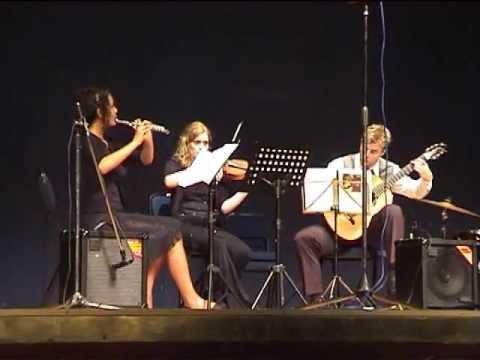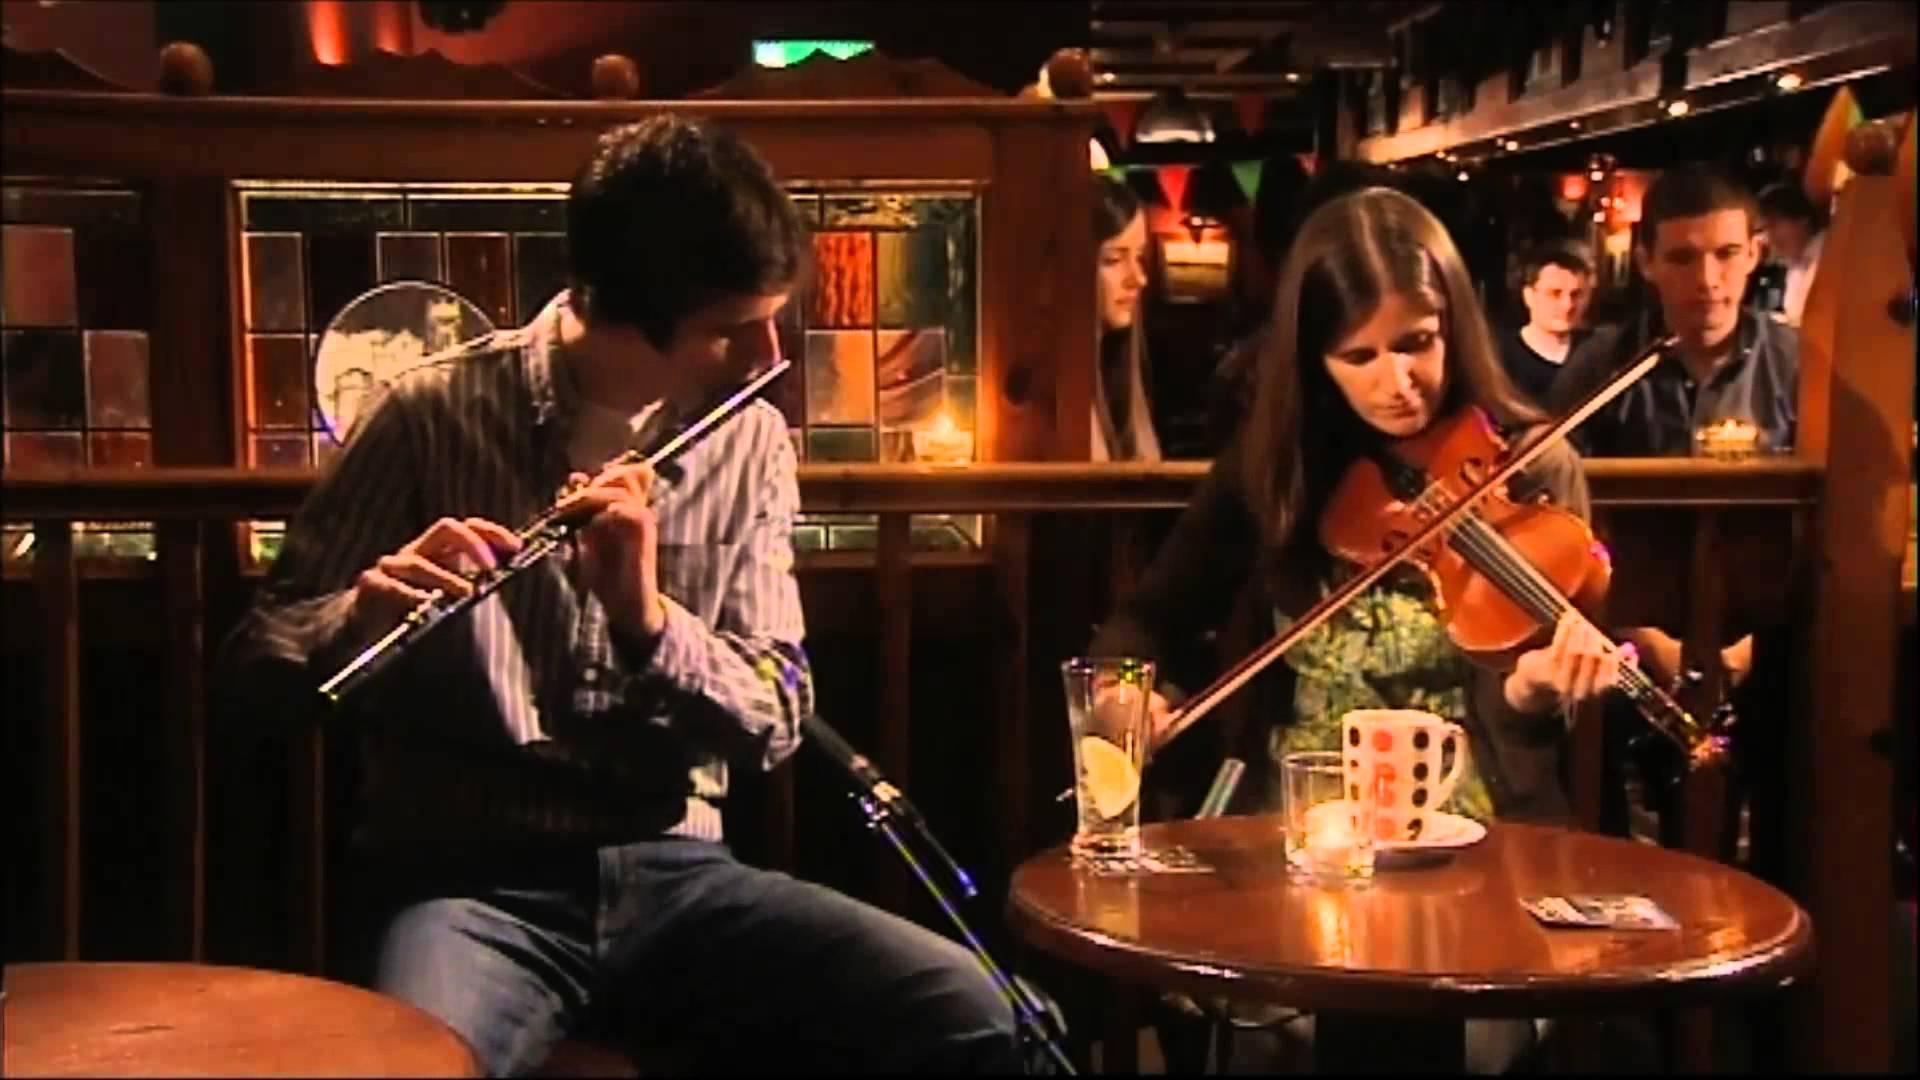The first image is the image on the left, the second image is the image on the right. For the images displayed, is the sentence "The image on the left shows an instrumental group with at least four members, and all members sitting on chairs." factually correct? Answer yes or no. No. The first image is the image on the left, the second image is the image on the right. Analyze the images presented: Is the assertion "The image on the left shows a violin player and a flute player sitting side by side." valid? Answer yes or no. Yes. 